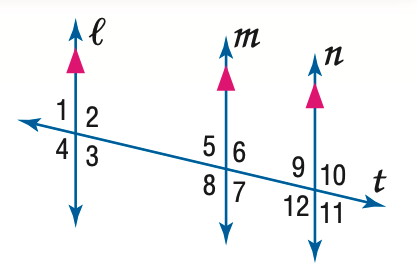Answer the mathemtical geometry problem and directly provide the correct option letter.
Question: In the figure, m \angle 9 = 75. Find the measure of \angle 8.
Choices: A: 75 B: 85 C: 95 D: 105 D 